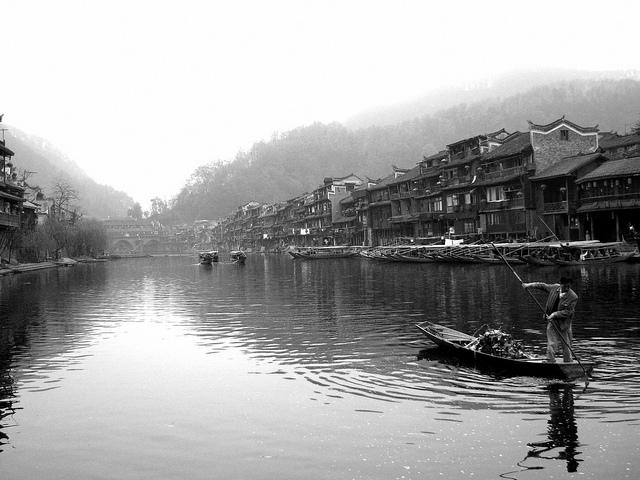Which type action propels the nearest boat forward? Please explain your reasoning. poking. The action is poking. 